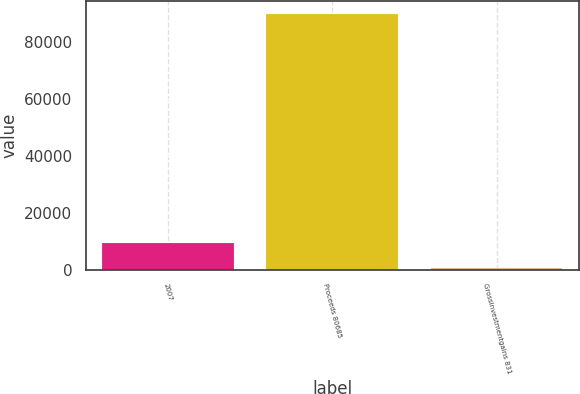Convert chart to OTSL. <chart><loc_0><loc_0><loc_500><loc_500><bar_chart><fcel>2007<fcel>Proceeds 80685<fcel>Grossinvestmentgains 831<nl><fcel>9508.9<fcel>89869<fcel>580<nl></chart> 